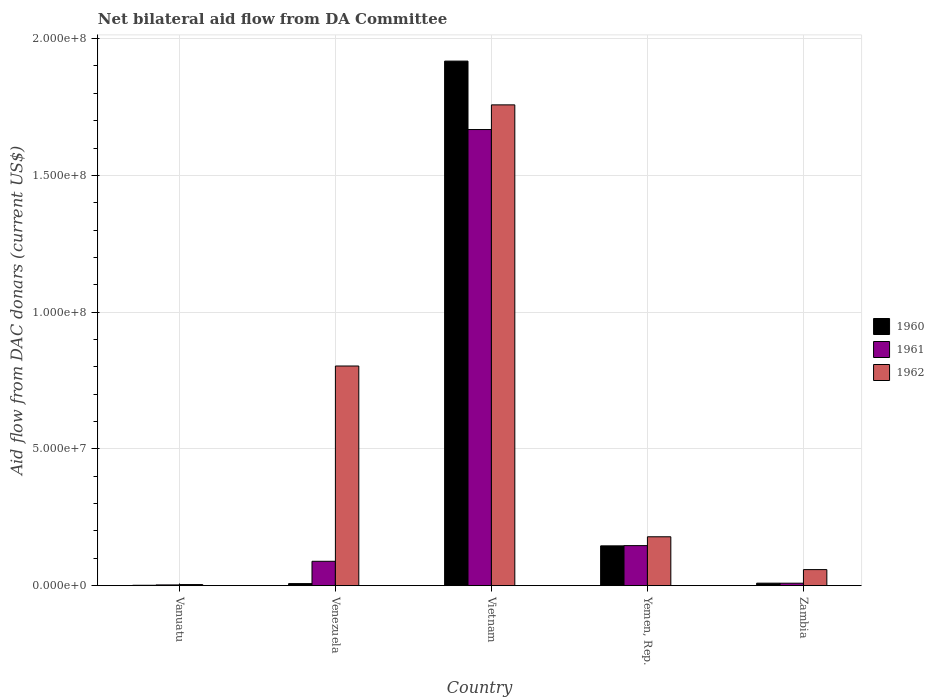Are the number of bars on each tick of the X-axis equal?
Your answer should be very brief. Yes. What is the label of the 5th group of bars from the left?
Your answer should be compact. Zambia. In how many cases, is the number of bars for a given country not equal to the number of legend labels?
Make the answer very short. 0. What is the aid flow in in 1960 in Venezuela?
Offer a very short reply. 7.60e+05. Across all countries, what is the maximum aid flow in in 1962?
Your answer should be very brief. 1.76e+08. Across all countries, what is the minimum aid flow in in 1960?
Give a very brief answer. 1.50e+05. In which country was the aid flow in in 1962 maximum?
Offer a terse response. Vietnam. In which country was the aid flow in in 1961 minimum?
Ensure brevity in your answer.  Vanuatu. What is the total aid flow in in 1962 in the graph?
Offer a very short reply. 2.80e+08. What is the difference between the aid flow in in 1961 in Vietnam and that in Yemen, Rep.?
Provide a succinct answer. 1.52e+08. What is the difference between the aid flow in in 1962 in Vietnam and the aid flow in in 1961 in Venezuela?
Keep it short and to the point. 1.67e+08. What is the average aid flow in in 1961 per country?
Keep it short and to the point. 3.83e+07. What is the difference between the aid flow in of/in 1961 and aid flow in of/in 1960 in Venezuela?
Provide a short and direct response. 8.16e+06. What is the ratio of the aid flow in in 1960 in Yemen, Rep. to that in Zambia?
Make the answer very short. 15.83. Is the difference between the aid flow in in 1961 in Yemen, Rep. and Zambia greater than the difference between the aid flow in in 1960 in Yemen, Rep. and Zambia?
Offer a very short reply. Yes. What is the difference between the highest and the second highest aid flow in in 1962?
Your answer should be compact. 9.55e+07. What is the difference between the highest and the lowest aid flow in in 1961?
Keep it short and to the point. 1.66e+08. Is the sum of the aid flow in in 1961 in Vanuatu and Venezuela greater than the maximum aid flow in in 1960 across all countries?
Ensure brevity in your answer.  No. Is it the case that in every country, the sum of the aid flow in in 1960 and aid flow in in 1962 is greater than the aid flow in in 1961?
Your response must be concise. Yes. Are all the bars in the graph horizontal?
Offer a terse response. No. How many countries are there in the graph?
Your answer should be very brief. 5. What is the difference between two consecutive major ticks on the Y-axis?
Your answer should be compact. 5.00e+07. Are the values on the major ticks of Y-axis written in scientific E-notation?
Your answer should be compact. Yes. Does the graph contain any zero values?
Your answer should be very brief. No. Where does the legend appear in the graph?
Your response must be concise. Center right. What is the title of the graph?
Ensure brevity in your answer.  Net bilateral aid flow from DA Committee. What is the label or title of the Y-axis?
Offer a terse response. Aid flow from DAC donars (current US$). What is the Aid flow from DAC donars (current US$) in 1960 in Vanuatu?
Give a very brief answer. 1.50e+05. What is the Aid flow from DAC donars (current US$) of 1961 in Vanuatu?
Offer a terse response. 2.80e+05. What is the Aid flow from DAC donars (current US$) in 1960 in Venezuela?
Keep it short and to the point. 7.60e+05. What is the Aid flow from DAC donars (current US$) of 1961 in Venezuela?
Ensure brevity in your answer.  8.92e+06. What is the Aid flow from DAC donars (current US$) in 1962 in Venezuela?
Offer a terse response. 8.03e+07. What is the Aid flow from DAC donars (current US$) in 1960 in Vietnam?
Keep it short and to the point. 1.92e+08. What is the Aid flow from DAC donars (current US$) of 1961 in Vietnam?
Make the answer very short. 1.67e+08. What is the Aid flow from DAC donars (current US$) in 1962 in Vietnam?
Your answer should be compact. 1.76e+08. What is the Aid flow from DAC donars (current US$) of 1960 in Yemen, Rep.?
Offer a very short reply. 1.46e+07. What is the Aid flow from DAC donars (current US$) in 1961 in Yemen, Rep.?
Offer a very short reply. 1.46e+07. What is the Aid flow from DAC donars (current US$) of 1962 in Yemen, Rep.?
Ensure brevity in your answer.  1.79e+07. What is the Aid flow from DAC donars (current US$) of 1960 in Zambia?
Your answer should be compact. 9.20e+05. What is the Aid flow from DAC donars (current US$) in 1961 in Zambia?
Give a very brief answer. 9.10e+05. What is the Aid flow from DAC donars (current US$) of 1962 in Zambia?
Offer a terse response. 5.88e+06. Across all countries, what is the maximum Aid flow from DAC donars (current US$) of 1960?
Provide a succinct answer. 1.92e+08. Across all countries, what is the maximum Aid flow from DAC donars (current US$) in 1961?
Make the answer very short. 1.67e+08. Across all countries, what is the maximum Aid flow from DAC donars (current US$) of 1962?
Keep it short and to the point. 1.76e+08. Across all countries, what is the minimum Aid flow from DAC donars (current US$) of 1960?
Keep it short and to the point. 1.50e+05. Across all countries, what is the minimum Aid flow from DAC donars (current US$) of 1962?
Your response must be concise. 4.10e+05. What is the total Aid flow from DAC donars (current US$) in 1960 in the graph?
Ensure brevity in your answer.  2.08e+08. What is the total Aid flow from DAC donars (current US$) in 1961 in the graph?
Your answer should be compact. 1.92e+08. What is the total Aid flow from DAC donars (current US$) of 1962 in the graph?
Your answer should be very brief. 2.80e+08. What is the difference between the Aid flow from DAC donars (current US$) in 1960 in Vanuatu and that in Venezuela?
Your answer should be very brief. -6.10e+05. What is the difference between the Aid flow from DAC donars (current US$) in 1961 in Vanuatu and that in Venezuela?
Your answer should be very brief. -8.64e+06. What is the difference between the Aid flow from DAC donars (current US$) of 1962 in Vanuatu and that in Venezuela?
Provide a succinct answer. -7.99e+07. What is the difference between the Aid flow from DAC donars (current US$) in 1960 in Vanuatu and that in Vietnam?
Keep it short and to the point. -1.92e+08. What is the difference between the Aid flow from DAC donars (current US$) in 1961 in Vanuatu and that in Vietnam?
Your answer should be compact. -1.66e+08. What is the difference between the Aid flow from DAC donars (current US$) in 1962 in Vanuatu and that in Vietnam?
Offer a terse response. -1.75e+08. What is the difference between the Aid flow from DAC donars (current US$) in 1960 in Vanuatu and that in Yemen, Rep.?
Your response must be concise. -1.44e+07. What is the difference between the Aid flow from DAC donars (current US$) in 1961 in Vanuatu and that in Yemen, Rep.?
Provide a succinct answer. -1.44e+07. What is the difference between the Aid flow from DAC donars (current US$) in 1962 in Vanuatu and that in Yemen, Rep.?
Your answer should be compact. -1.75e+07. What is the difference between the Aid flow from DAC donars (current US$) in 1960 in Vanuatu and that in Zambia?
Provide a succinct answer. -7.70e+05. What is the difference between the Aid flow from DAC donars (current US$) of 1961 in Vanuatu and that in Zambia?
Your answer should be very brief. -6.30e+05. What is the difference between the Aid flow from DAC donars (current US$) of 1962 in Vanuatu and that in Zambia?
Offer a terse response. -5.47e+06. What is the difference between the Aid flow from DAC donars (current US$) in 1960 in Venezuela and that in Vietnam?
Ensure brevity in your answer.  -1.91e+08. What is the difference between the Aid flow from DAC donars (current US$) of 1961 in Venezuela and that in Vietnam?
Provide a succinct answer. -1.58e+08. What is the difference between the Aid flow from DAC donars (current US$) of 1962 in Venezuela and that in Vietnam?
Your answer should be very brief. -9.55e+07. What is the difference between the Aid flow from DAC donars (current US$) in 1960 in Venezuela and that in Yemen, Rep.?
Make the answer very short. -1.38e+07. What is the difference between the Aid flow from DAC donars (current US$) in 1961 in Venezuela and that in Yemen, Rep.?
Your response must be concise. -5.73e+06. What is the difference between the Aid flow from DAC donars (current US$) of 1962 in Venezuela and that in Yemen, Rep.?
Offer a terse response. 6.24e+07. What is the difference between the Aid flow from DAC donars (current US$) of 1960 in Venezuela and that in Zambia?
Your answer should be very brief. -1.60e+05. What is the difference between the Aid flow from DAC donars (current US$) of 1961 in Venezuela and that in Zambia?
Ensure brevity in your answer.  8.01e+06. What is the difference between the Aid flow from DAC donars (current US$) of 1962 in Venezuela and that in Zambia?
Make the answer very short. 7.44e+07. What is the difference between the Aid flow from DAC donars (current US$) of 1960 in Vietnam and that in Yemen, Rep.?
Provide a succinct answer. 1.77e+08. What is the difference between the Aid flow from DAC donars (current US$) of 1961 in Vietnam and that in Yemen, Rep.?
Offer a very short reply. 1.52e+08. What is the difference between the Aid flow from DAC donars (current US$) in 1962 in Vietnam and that in Yemen, Rep.?
Your answer should be compact. 1.58e+08. What is the difference between the Aid flow from DAC donars (current US$) in 1960 in Vietnam and that in Zambia?
Offer a very short reply. 1.91e+08. What is the difference between the Aid flow from DAC donars (current US$) of 1961 in Vietnam and that in Zambia?
Your answer should be compact. 1.66e+08. What is the difference between the Aid flow from DAC donars (current US$) of 1962 in Vietnam and that in Zambia?
Keep it short and to the point. 1.70e+08. What is the difference between the Aid flow from DAC donars (current US$) in 1960 in Yemen, Rep. and that in Zambia?
Provide a short and direct response. 1.36e+07. What is the difference between the Aid flow from DAC donars (current US$) of 1961 in Yemen, Rep. and that in Zambia?
Offer a very short reply. 1.37e+07. What is the difference between the Aid flow from DAC donars (current US$) in 1962 in Yemen, Rep. and that in Zambia?
Your response must be concise. 1.20e+07. What is the difference between the Aid flow from DAC donars (current US$) of 1960 in Vanuatu and the Aid flow from DAC donars (current US$) of 1961 in Venezuela?
Offer a terse response. -8.77e+06. What is the difference between the Aid flow from DAC donars (current US$) in 1960 in Vanuatu and the Aid flow from DAC donars (current US$) in 1962 in Venezuela?
Give a very brief answer. -8.02e+07. What is the difference between the Aid flow from DAC donars (current US$) in 1961 in Vanuatu and the Aid flow from DAC donars (current US$) in 1962 in Venezuela?
Provide a succinct answer. -8.00e+07. What is the difference between the Aid flow from DAC donars (current US$) in 1960 in Vanuatu and the Aid flow from DAC donars (current US$) in 1961 in Vietnam?
Offer a terse response. -1.67e+08. What is the difference between the Aid flow from DAC donars (current US$) of 1960 in Vanuatu and the Aid flow from DAC donars (current US$) of 1962 in Vietnam?
Keep it short and to the point. -1.76e+08. What is the difference between the Aid flow from DAC donars (current US$) in 1961 in Vanuatu and the Aid flow from DAC donars (current US$) in 1962 in Vietnam?
Offer a terse response. -1.76e+08. What is the difference between the Aid flow from DAC donars (current US$) of 1960 in Vanuatu and the Aid flow from DAC donars (current US$) of 1961 in Yemen, Rep.?
Give a very brief answer. -1.45e+07. What is the difference between the Aid flow from DAC donars (current US$) in 1960 in Vanuatu and the Aid flow from DAC donars (current US$) in 1962 in Yemen, Rep.?
Give a very brief answer. -1.77e+07. What is the difference between the Aid flow from DAC donars (current US$) in 1961 in Vanuatu and the Aid flow from DAC donars (current US$) in 1962 in Yemen, Rep.?
Your response must be concise. -1.76e+07. What is the difference between the Aid flow from DAC donars (current US$) in 1960 in Vanuatu and the Aid flow from DAC donars (current US$) in 1961 in Zambia?
Make the answer very short. -7.60e+05. What is the difference between the Aid flow from DAC donars (current US$) of 1960 in Vanuatu and the Aid flow from DAC donars (current US$) of 1962 in Zambia?
Provide a succinct answer. -5.73e+06. What is the difference between the Aid flow from DAC donars (current US$) of 1961 in Vanuatu and the Aid flow from DAC donars (current US$) of 1962 in Zambia?
Your answer should be compact. -5.60e+06. What is the difference between the Aid flow from DAC donars (current US$) of 1960 in Venezuela and the Aid flow from DAC donars (current US$) of 1961 in Vietnam?
Provide a short and direct response. -1.66e+08. What is the difference between the Aid flow from DAC donars (current US$) in 1960 in Venezuela and the Aid flow from DAC donars (current US$) in 1962 in Vietnam?
Provide a short and direct response. -1.75e+08. What is the difference between the Aid flow from DAC donars (current US$) in 1961 in Venezuela and the Aid flow from DAC donars (current US$) in 1962 in Vietnam?
Make the answer very short. -1.67e+08. What is the difference between the Aid flow from DAC donars (current US$) of 1960 in Venezuela and the Aid flow from DAC donars (current US$) of 1961 in Yemen, Rep.?
Provide a succinct answer. -1.39e+07. What is the difference between the Aid flow from DAC donars (current US$) of 1960 in Venezuela and the Aid flow from DAC donars (current US$) of 1962 in Yemen, Rep.?
Your answer should be compact. -1.71e+07. What is the difference between the Aid flow from DAC donars (current US$) of 1961 in Venezuela and the Aid flow from DAC donars (current US$) of 1962 in Yemen, Rep.?
Your response must be concise. -8.96e+06. What is the difference between the Aid flow from DAC donars (current US$) of 1960 in Venezuela and the Aid flow from DAC donars (current US$) of 1962 in Zambia?
Ensure brevity in your answer.  -5.12e+06. What is the difference between the Aid flow from DAC donars (current US$) in 1961 in Venezuela and the Aid flow from DAC donars (current US$) in 1962 in Zambia?
Give a very brief answer. 3.04e+06. What is the difference between the Aid flow from DAC donars (current US$) of 1960 in Vietnam and the Aid flow from DAC donars (current US$) of 1961 in Yemen, Rep.?
Provide a short and direct response. 1.77e+08. What is the difference between the Aid flow from DAC donars (current US$) of 1960 in Vietnam and the Aid flow from DAC donars (current US$) of 1962 in Yemen, Rep.?
Keep it short and to the point. 1.74e+08. What is the difference between the Aid flow from DAC donars (current US$) in 1961 in Vietnam and the Aid flow from DAC donars (current US$) in 1962 in Yemen, Rep.?
Provide a succinct answer. 1.49e+08. What is the difference between the Aid flow from DAC donars (current US$) in 1960 in Vietnam and the Aid flow from DAC donars (current US$) in 1961 in Zambia?
Give a very brief answer. 1.91e+08. What is the difference between the Aid flow from DAC donars (current US$) of 1960 in Vietnam and the Aid flow from DAC donars (current US$) of 1962 in Zambia?
Your answer should be compact. 1.86e+08. What is the difference between the Aid flow from DAC donars (current US$) in 1961 in Vietnam and the Aid flow from DAC donars (current US$) in 1962 in Zambia?
Your answer should be compact. 1.61e+08. What is the difference between the Aid flow from DAC donars (current US$) in 1960 in Yemen, Rep. and the Aid flow from DAC donars (current US$) in 1961 in Zambia?
Make the answer very short. 1.36e+07. What is the difference between the Aid flow from DAC donars (current US$) of 1960 in Yemen, Rep. and the Aid flow from DAC donars (current US$) of 1962 in Zambia?
Keep it short and to the point. 8.68e+06. What is the difference between the Aid flow from DAC donars (current US$) in 1961 in Yemen, Rep. and the Aid flow from DAC donars (current US$) in 1962 in Zambia?
Ensure brevity in your answer.  8.77e+06. What is the average Aid flow from DAC donars (current US$) in 1960 per country?
Offer a terse response. 4.16e+07. What is the average Aid flow from DAC donars (current US$) in 1961 per country?
Keep it short and to the point. 3.83e+07. What is the average Aid flow from DAC donars (current US$) in 1962 per country?
Offer a very short reply. 5.61e+07. What is the difference between the Aid flow from DAC donars (current US$) of 1960 and Aid flow from DAC donars (current US$) of 1961 in Vanuatu?
Your response must be concise. -1.30e+05. What is the difference between the Aid flow from DAC donars (current US$) in 1960 and Aid flow from DAC donars (current US$) in 1961 in Venezuela?
Your answer should be compact. -8.16e+06. What is the difference between the Aid flow from DAC donars (current US$) in 1960 and Aid flow from DAC donars (current US$) in 1962 in Venezuela?
Give a very brief answer. -7.96e+07. What is the difference between the Aid flow from DAC donars (current US$) in 1961 and Aid flow from DAC donars (current US$) in 1962 in Venezuela?
Ensure brevity in your answer.  -7.14e+07. What is the difference between the Aid flow from DAC donars (current US$) in 1960 and Aid flow from DAC donars (current US$) in 1961 in Vietnam?
Your answer should be compact. 2.50e+07. What is the difference between the Aid flow from DAC donars (current US$) in 1960 and Aid flow from DAC donars (current US$) in 1962 in Vietnam?
Your response must be concise. 1.60e+07. What is the difference between the Aid flow from DAC donars (current US$) of 1961 and Aid flow from DAC donars (current US$) of 1962 in Vietnam?
Keep it short and to the point. -9.02e+06. What is the difference between the Aid flow from DAC donars (current US$) in 1960 and Aid flow from DAC donars (current US$) in 1962 in Yemen, Rep.?
Provide a short and direct response. -3.32e+06. What is the difference between the Aid flow from DAC donars (current US$) in 1961 and Aid flow from DAC donars (current US$) in 1962 in Yemen, Rep.?
Provide a succinct answer. -3.23e+06. What is the difference between the Aid flow from DAC donars (current US$) in 1960 and Aid flow from DAC donars (current US$) in 1961 in Zambia?
Make the answer very short. 10000. What is the difference between the Aid flow from DAC donars (current US$) of 1960 and Aid flow from DAC donars (current US$) of 1962 in Zambia?
Provide a short and direct response. -4.96e+06. What is the difference between the Aid flow from DAC donars (current US$) of 1961 and Aid flow from DAC donars (current US$) of 1962 in Zambia?
Your answer should be compact. -4.97e+06. What is the ratio of the Aid flow from DAC donars (current US$) of 1960 in Vanuatu to that in Venezuela?
Offer a very short reply. 0.2. What is the ratio of the Aid flow from DAC donars (current US$) in 1961 in Vanuatu to that in Venezuela?
Your answer should be compact. 0.03. What is the ratio of the Aid flow from DAC donars (current US$) of 1962 in Vanuatu to that in Venezuela?
Your answer should be compact. 0.01. What is the ratio of the Aid flow from DAC donars (current US$) of 1960 in Vanuatu to that in Vietnam?
Make the answer very short. 0. What is the ratio of the Aid flow from DAC donars (current US$) in 1961 in Vanuatu to that in Vietnam?
Ensure brevity in your answer.  0. What is the ratio of the Aid flow from DAC donars (current US$) in 1962 in Vanuatu to that in Vietnam?
Offer a terse response. 0. What is the ratio of the Aid flow from DAC donars (current US$) in 1960 in Vanuatu to that in Yemen, Rep.?
Ensure brevity in your answer.  0.01. What is the ratio of the Aid flow from DAC donars (current US$) of 1961 in Vanuatu to that in Yemen, Rep.?
Keep it short and to the point. 0.02. What is the ratio of the Aid flow from DAC donars (current US$) in 1962 in Vanuatu to that in Yemen, Rep.?
Ensure brevity in your answer.  0.02. What is the ratio of the Aid flow from DAC donars (current US$) of 1960 in Vanuatu to that in Zambia?
Give a very brief answer. 0.16. What is the ratio of the Aid flow from DAC donars (current US$) of 1961 in Vanuatu to that in Zambia?
Your answer should be compact. 0.31. What is the ratio of the Aid flow from DAC donars (current US$) of 1962 in Vanuatu to that in Zambia?
Give a very brief answer. 0.07. What is the ratio of the Aid flow from DAC donars (current US$) in 1960 in Venezuela to that in Vietnam?
Provide a short and direct response. 0. What is the ratio of the Aid flow from DAC donars (current US$) in 1961 in Venezuela to that in Vietnam?
Provide a short and direct response. 0.05. What is the ratio of the Aid flow from DAC donars (current US$) of 1962 in Venezuela to that in Vietnam?
Ensure brevity in your answer.  0.46. What is the ratio of the Aid flow from DAC donars (current US$) of 1960 in Venezuela to that in Yemen, Rep.?
Provide a short and direct response. 0.05. What is the ratio of the Aid flow from DAC donars (current US$) in 1961 in Venezuela to that in Yemen, Rep.?
Provide a short and direct response. 0.61. What is the ratio of the Aid flow from DAC donars (current US$) in 1962 in Venezuela to that in Yemen, Rep.?
Provide a succinct answer. 4.49. What is the ratio of the Aid flow from DAC donars (current US$) of 1960 in Venezuela to that in Zambia?
Offer a very short reply. 0.83. What is the ratio of the Aid flow from DAC donars (current US$) of 1961 in Venezuela to that in Zambia?
Ensure brevity in your answer.  9.8. What is the ratio of the Aid flow from DAC donars (current US$) in 1962 in Venezuela to that in Zambia?
Provide a succinct answer. 13.66. What is the ratio of the Aid flow from DAC donars (current US$) in 1960 in Vietnam to that in Yemen, Rep.?
Give a very brief answer. 13.17. What is the ratio of the Aid flow from DAC donars (current US$) of 1961 in Vietnam to that in Yemen, Rep.?
Your answer should be compact. 11.38. What is the ratio of the Aid flow from DAC donars (current US$) of 1962 in Vietnam to that in Yemen, Rep.?
Your answer should be compact. 9.83. What is the ratio of the Aid flow from DAC donars (current US$) of 1960 in Vietnam to that in Zambia?
Keep it short and to the point. 208.46. What is the ratio of the Aid flow from DAC donars (current US$) in 1961 in Vietnam to that in Zambia?
Provide a short and direct response. 183.25. What is the ratio of the Aid flow from DAC donars (current US$) of 1962 in Vietnam to that in Zambia?
Your response must be concise. 29.89. What is the ratio of the Aid flow from DAC donars (current US$) in 1960 in Yemen, Rep. to that in Zambia?
Offer a terse response. 15.83. What is the ratio of the Aid flow from DAC donars (current US$) of 1961 in Yemen, Rep. to that in Zambia?
Make the answer very short. 16.1. What is the ratio of the Aid flow from DAC donars (current US$) of 1962 in Yemen, Rep. to that in Zambia?
Provide a short and direct response. 3.04. What is the difference between the highest and the second highest Aid flow from DAC donars (current US$) in 1960?
Keep it short and to the point. 1.77e+08. What is the difference between the highest and the second highest Aid flow from DAC donars (current US$) in 1961?
Provide a short and direct response. 1.52e+08. What is the difference between the highest and the second highest Aid flow from DAC donars (current US$) of 1962?
Keep it short and to the point. 9.55e+07. What is the difference between the highest and the lowest Aid flow from DAC donars (current US$) in 1960?
Keep it short and to the point. 1.92e+08. What is the difference between the highest and the lowest Aid flow from DAC donars (current US$) in 1961?
Provide a succinct answer. 1.66e+08. What is the difference between the highest and the lowest Aid flow from DAC donars (current US$) of 1962?
Keep it short and to the point. 1.75e+08. 